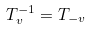Convert formula to latex. <formula><loc_0><loc_0><loc_500><loc_500>T _ { v } ^ { - 1 } = T _ { - v }</formula> 